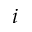Convert formula to latex. <formula><loc_0><loc_0><loc_500><loc_500>i</formula> 